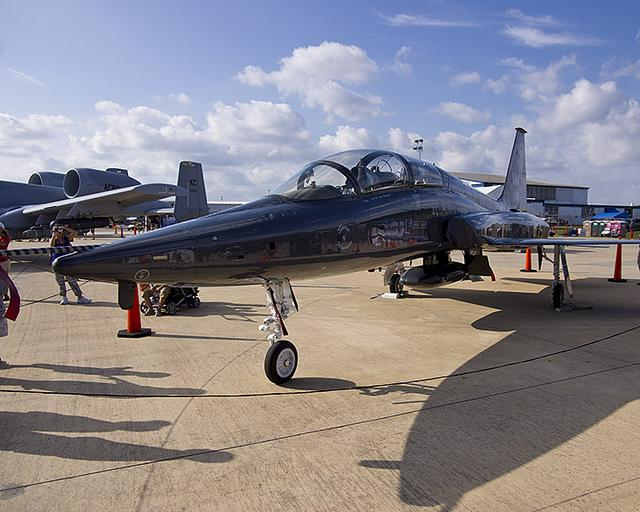Why is the plane parked here? Please explain your reasoning. on display. A plane is parked among others. people are walking around several planes taking pictures. 